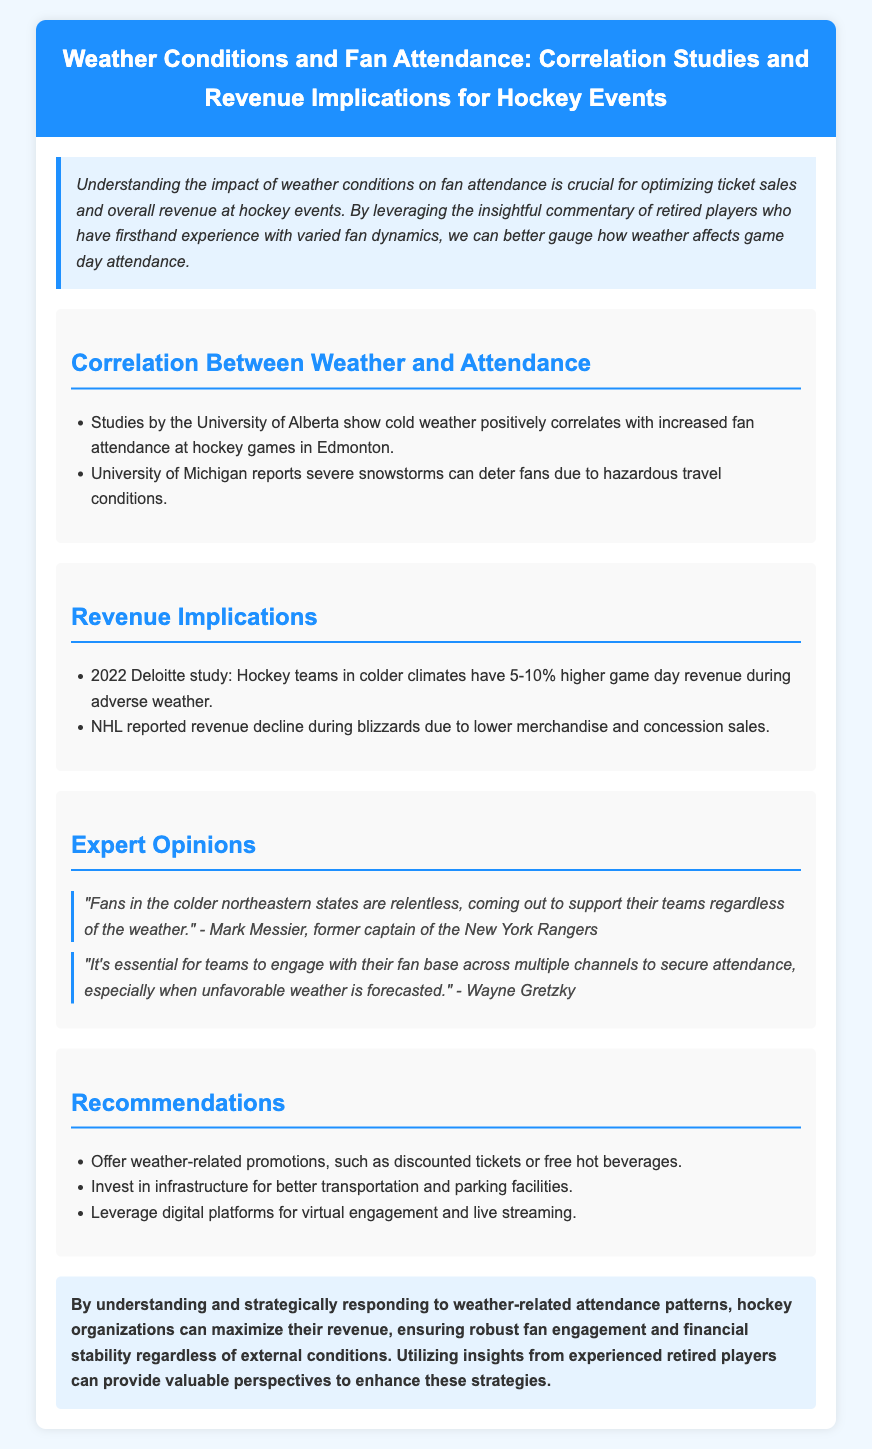What university reports that cold weather correlates positively with attendance? The University of Alberta conducted studies showing this correlation.
Answer: University of Alberta What is the revenue increase percentage for hockey teams in colder climates during adverse weather? According to a 2022 Deloitte study, this percentage is between 5-10%.
Answer: 5-10% Who commented on the relentless support of fans in colder states? The quote is attributed to Mark Messier, a former captain of the New York Rangers.
Answer: Mark Messier What do severe snowstorms do to fan attendance according to the University of Michigan? Severe snowstorms deter fans due to hazardous travel conditions.
Answer: Deter fans Which NHL-related issue is reported due to blizzard conditions? The NHL reported revenue decline due to lower merchandise and concession sales during blizzards.
Answer: Revenue decline What kind of promotions are recommended for weather-related issues? The document suggests offering discounted tickets or free hot beverages as weather-related promotions.
Answer: Discounted tickets or free hot beverages How should teams engage with their fan base according to Wayne Gretzky? Wayne Gretzky suggests engaging across multiple channels, especially with unfavorable weather forecasted.
Answer: Multiple channels What is the overall conclusion regarding weather-related attendance patterns? The conclusion emphasizes maximizing revenue through strategic responses to weather patterns.
Answer: Maximize revenue 